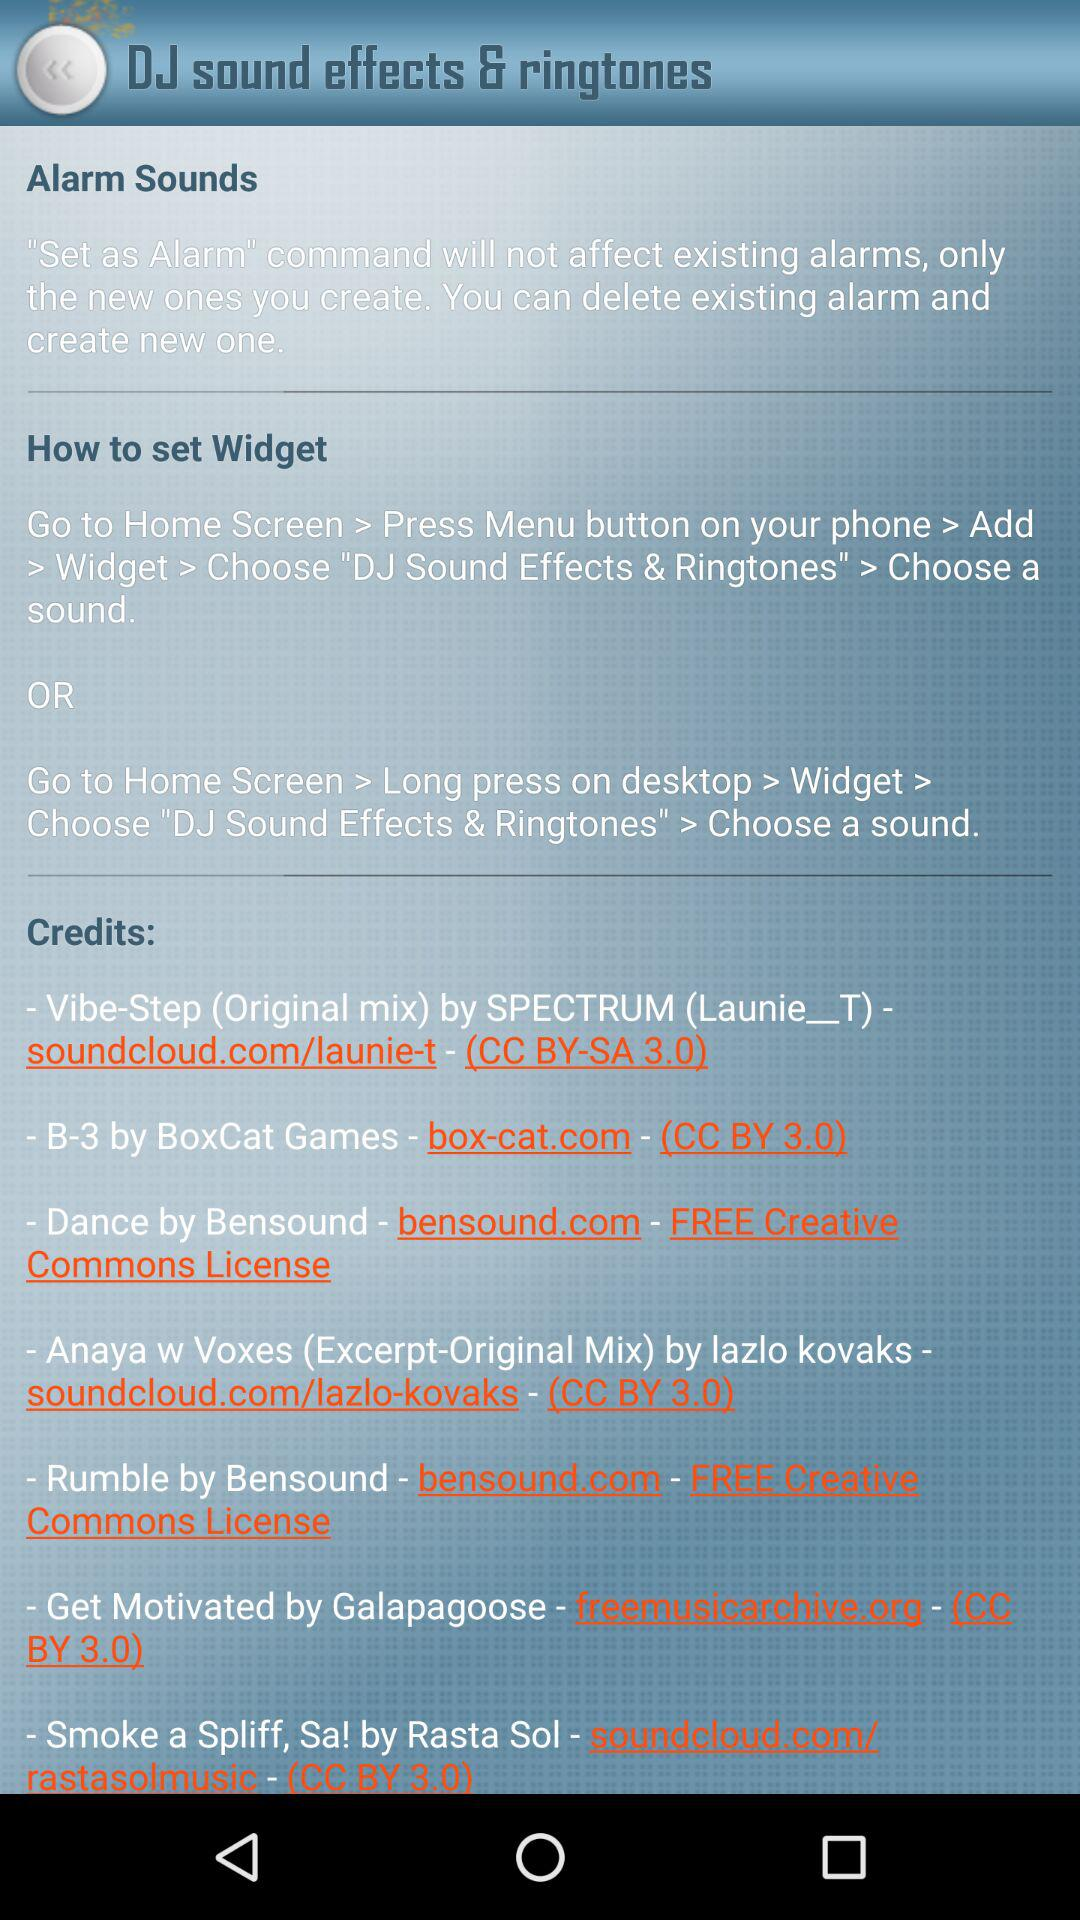Which sound effect is selected for the alarm?
When the provided information is insufficient, respond with <no answer>. <no answer> 